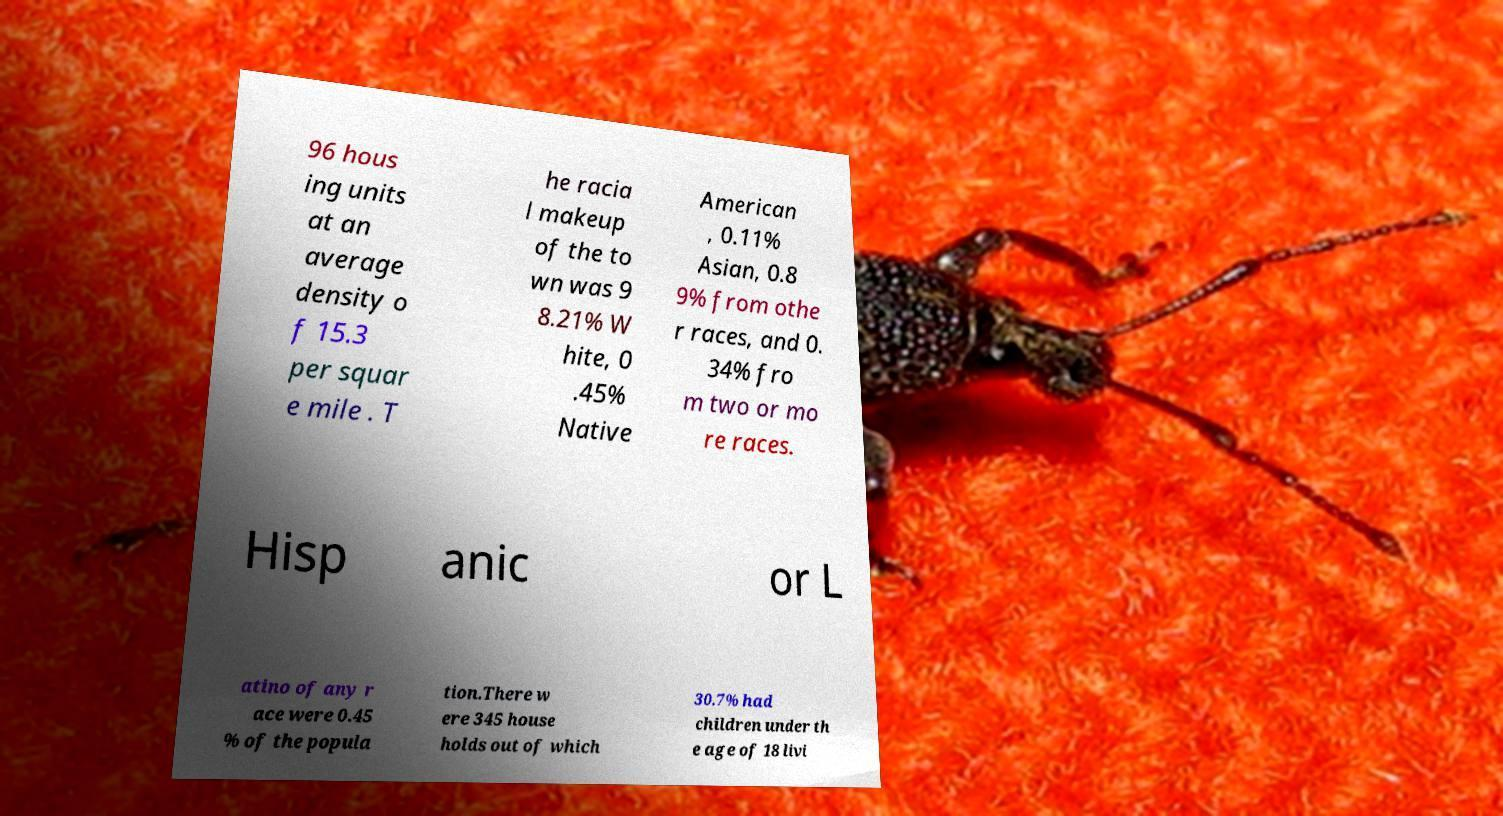Please read and relay the text visible in this image. What does it say? 96 hous ing units at an average density o f 15.3 per squar e mile . T he racia l makeup of the to wn was 9 8.21% W hite, 0 .45% Native American , 0.11% Asian, 0.8 9% from othe r races, and 0. 34% fro m two or mo re races. Hisp anic or L atino of any r ace were 0.45 % of the popula tion.There w ere 345 house holds out of which 30.7% had children under th e age of 18 livi 